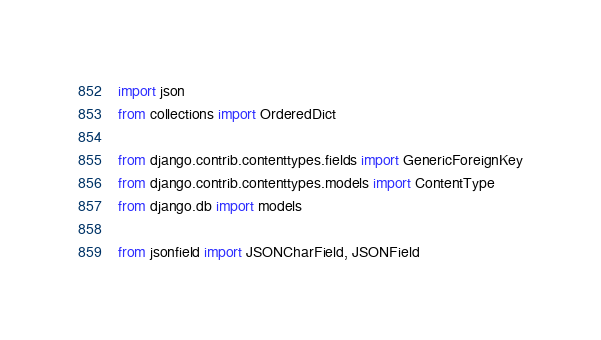Convert code to text. <code><loc_0><loc_0><loc_500><loc_500><_Python_>import json
from collections import OrderedDict

from django.contrib.contenttypes.fields import GenericForeignKey
from django.contrib.contenttypes.models import ContentType
from django.db import models

from jsonfield import JSONCharField, JSONField

</code> 